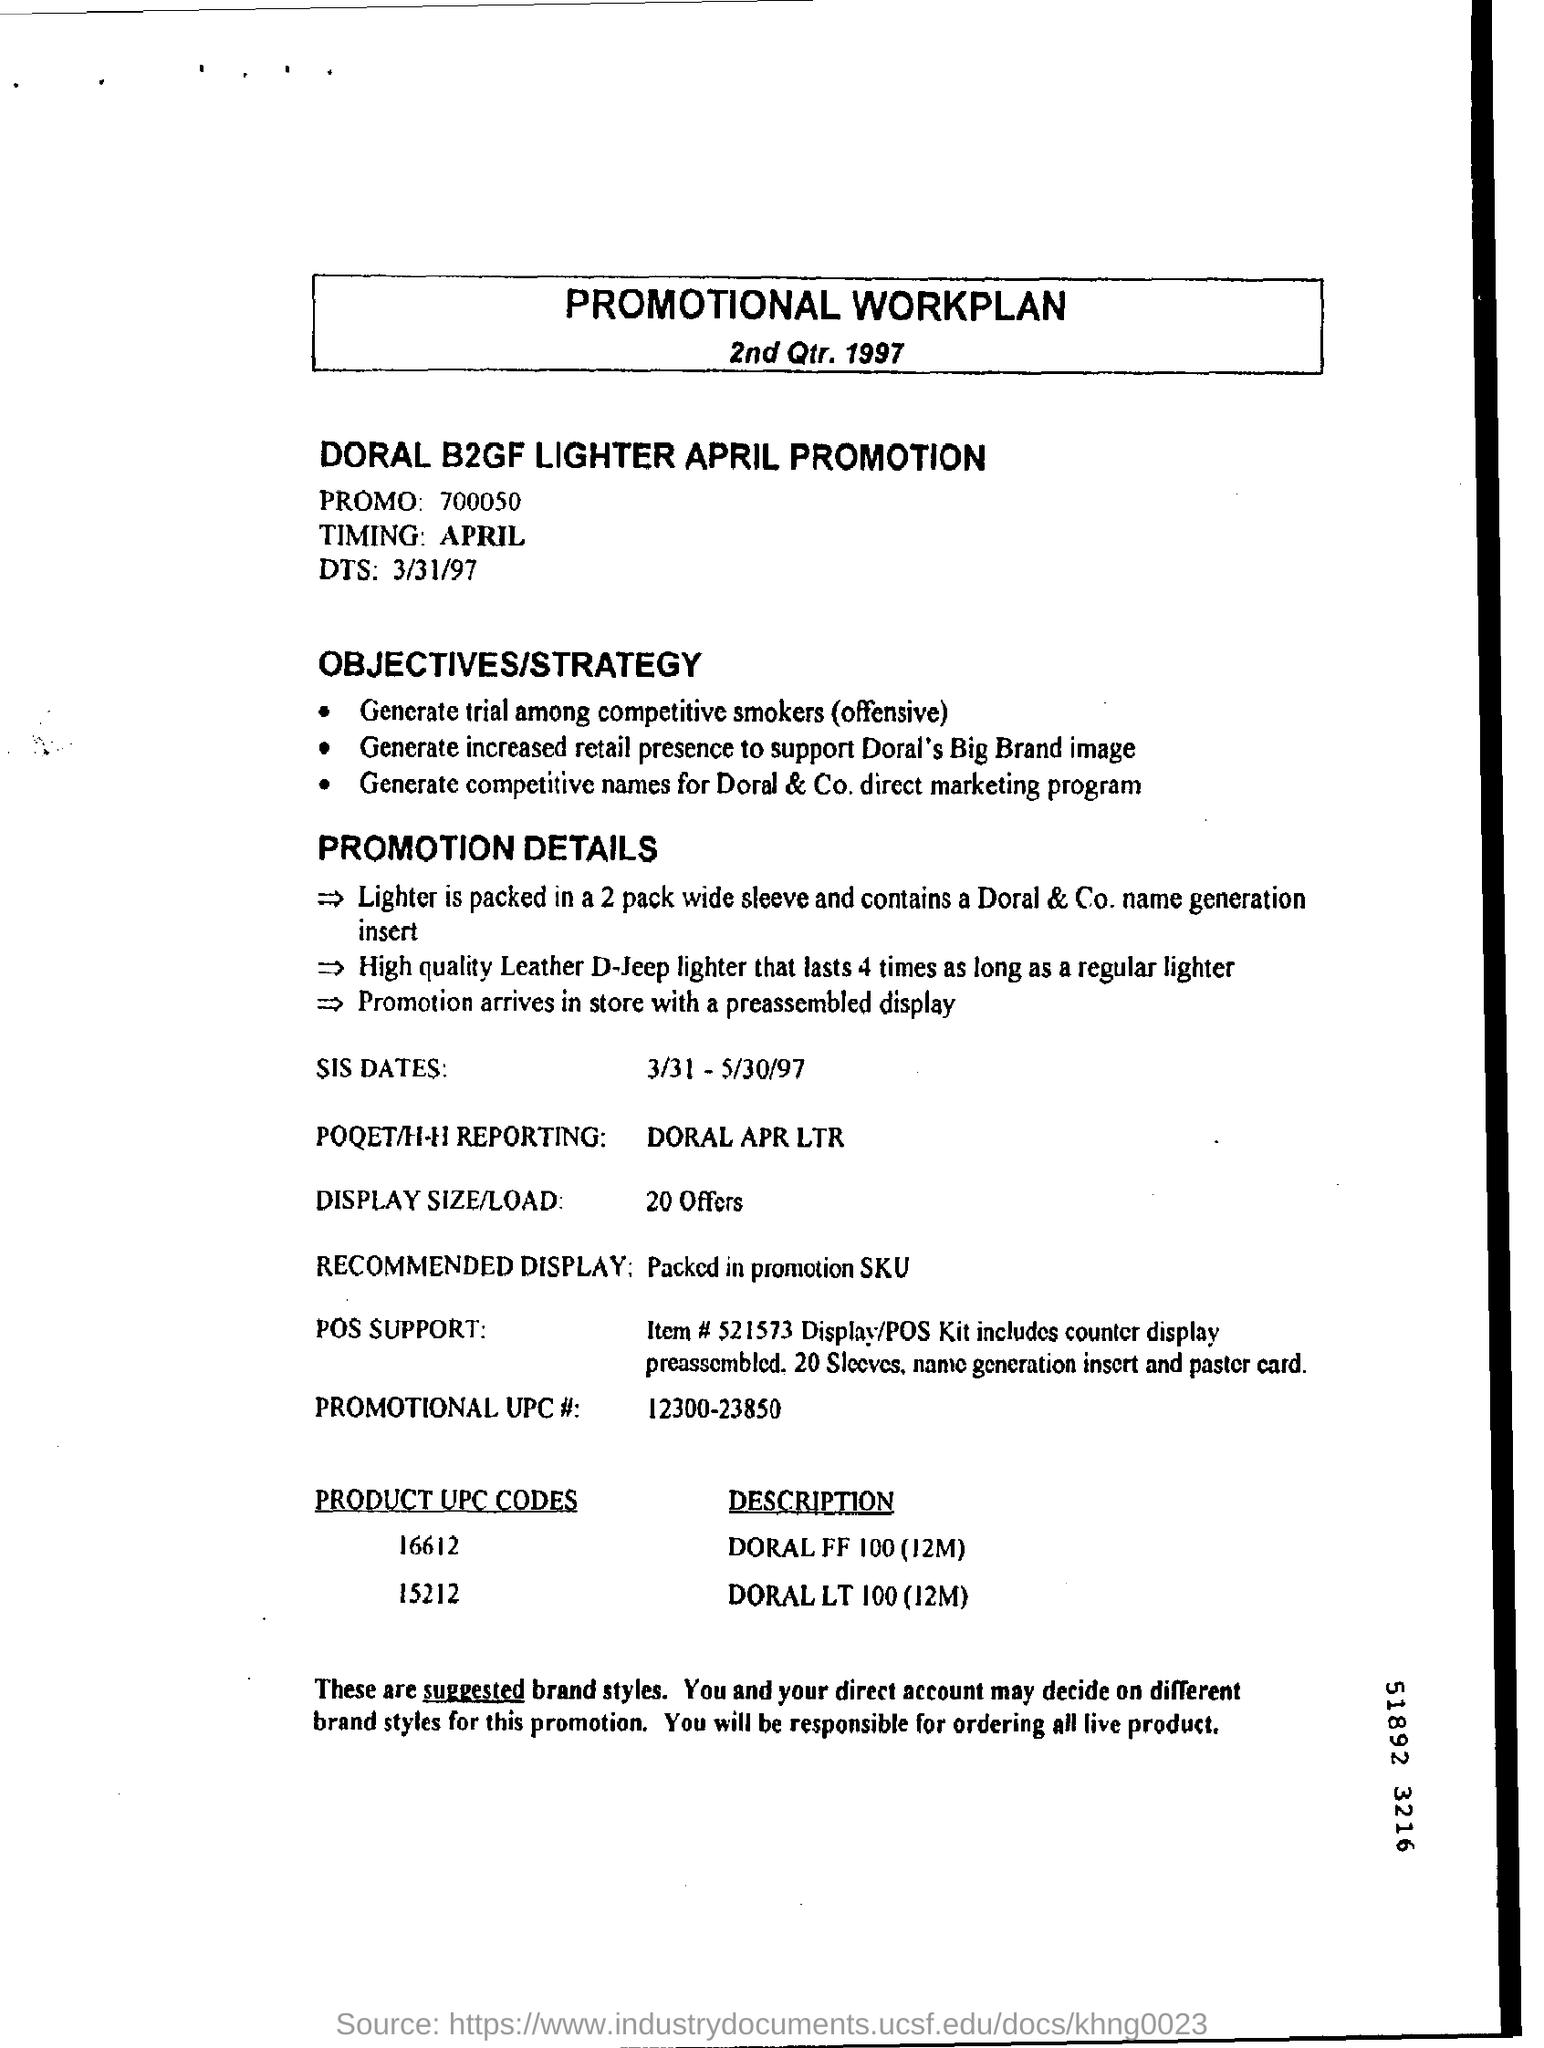What is the objective of this promotional work plan? The objective of this promotional work plan is to generate trial among competitive smokers, increase retail presence to support Doral's Big Brand image, and brainstorm competitive names for Doral & Co.'s direct marketing program. Can you detail the promotion specifics provided in the document? Certainly, the promotion details include the packaging of the lighter in a 2-pack wide sleeve box, containing a Doral & Co. name generation insert. The featured lighter, branded as D-jeeP, is noted for lasting four times longer than a regular lighter. 